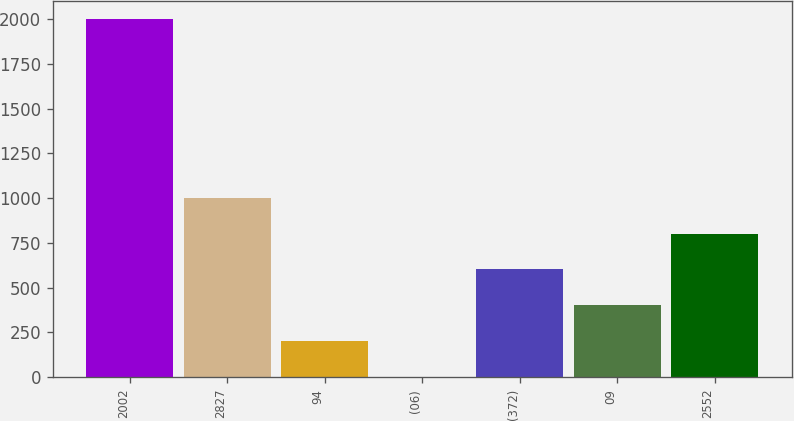<chart> <loc_0><loc_0><loc_500><loc_500><bar_chart><fcel>2002<fcel>2827<fcel>94<fcel>(06)<fcel>(372)<fcel>09<fcel>2552<nl><fcel>2001<fcel>1001.2<fcel>201.36<fcel>1.4<fcel>601.28<fcel>401.32<fcel>801.24<nl></chart> 